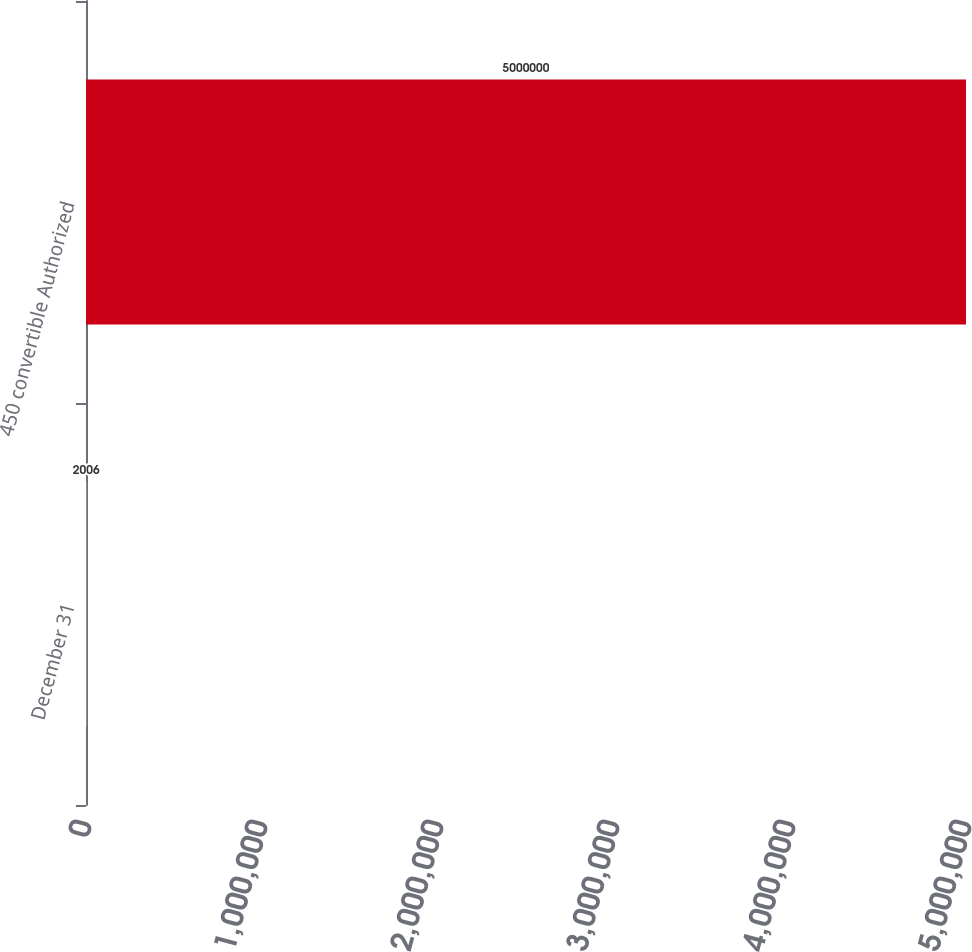<chart> <loc_0><loc_0><loc_500><loc_500><bar_chart><fcel>December 31<fcel>450 convertible Authorized<nl><fcel>2006<fcel>5e+06<nl></chart> 